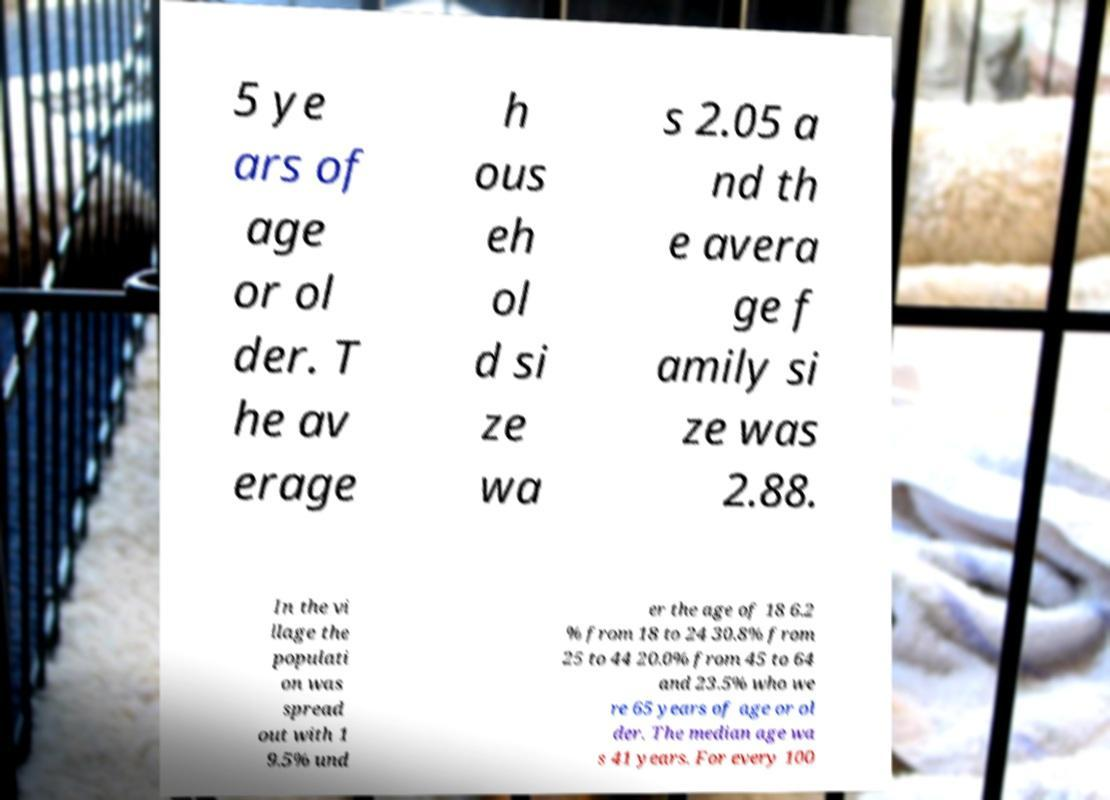Can you read and provide the text displayed in the image?This photo seems to have some interesting text. Can you extract and type it out for me? 5 ye ars of age or ol der. T he av erage h ous eh ol d si ze wa s 2.05 a nd th e avera ge f amily si ze was 2.88. In the vi llage the populati on was spread out with 1 9.5% und er the age of 18 6.2 % from 18 to 24 30.8% from 25 to 44 20.0% from 45 to 64 and 23.5% who we re 65 years of age or ol der. The median age wa s 41 years. For every 100 